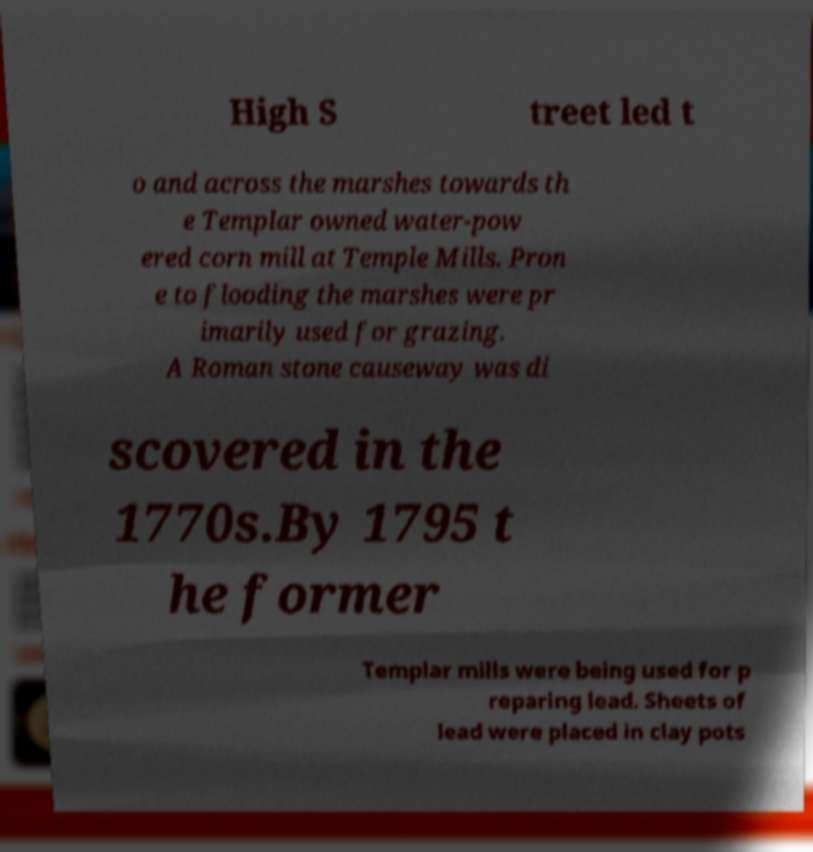Could you extract and type out the text from this image? High S treet led t o and across the marshes towards th e Templar owned water-pow ered corn mill at Temple Mills. Pron e to flooding the marshes were pr imarily used for grazing. A Roman stone causeway was di scovered in the 1770s.By 1795 t he former Templar mills were being used for p reparing lead. Sheets of lead were placed in clay pots 